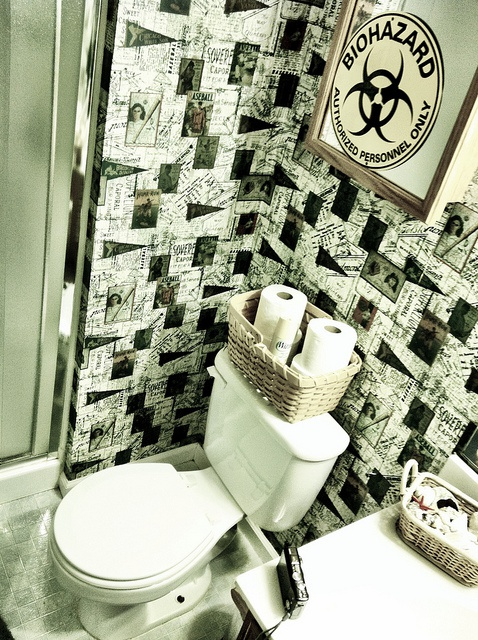Describe the objects in this image and their specific colors. I can see toilet in gray, ivory, beige, and darkgray tones, sink in gray, white, beige, tan, and olive tones, and handbag in gray, black, ivory, and darkgray tones in this image. 